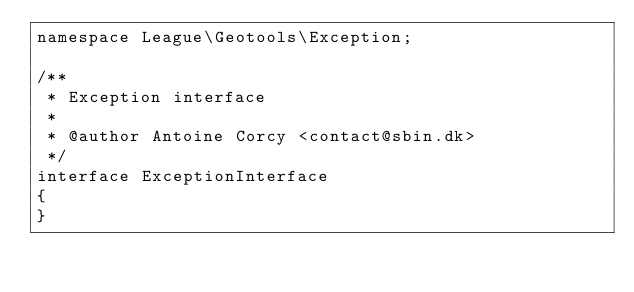Convert code to text. <code><loc_0><loc_0><loc_500><loc_500><_PHP_>namespace League\Geotools\Exception;

/**
 * Exception interface
 *
 * @author Antoine Corcy <contact@sbin.dk>
 */
interface ExceptionInterface
{
}
</code> 